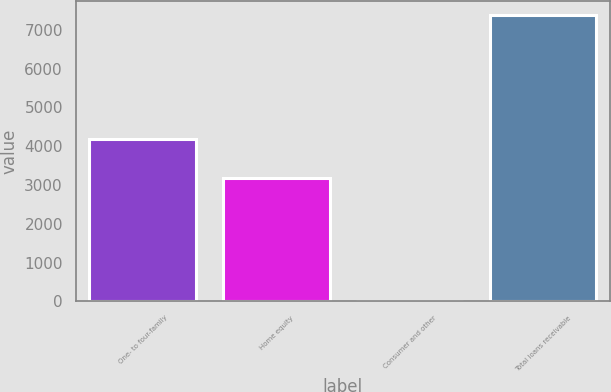<chart> <loc_0><loc_0><loc_500><loc_500><bar_chart><fcel>One- to four-family<fcel>Home equity<fcel>Consumer and other<fcel>Total loans receivable<nl><fcel>4175.3<fcel>3194.8<fcel>7.2<fcel>7377.3<nl></chart> 